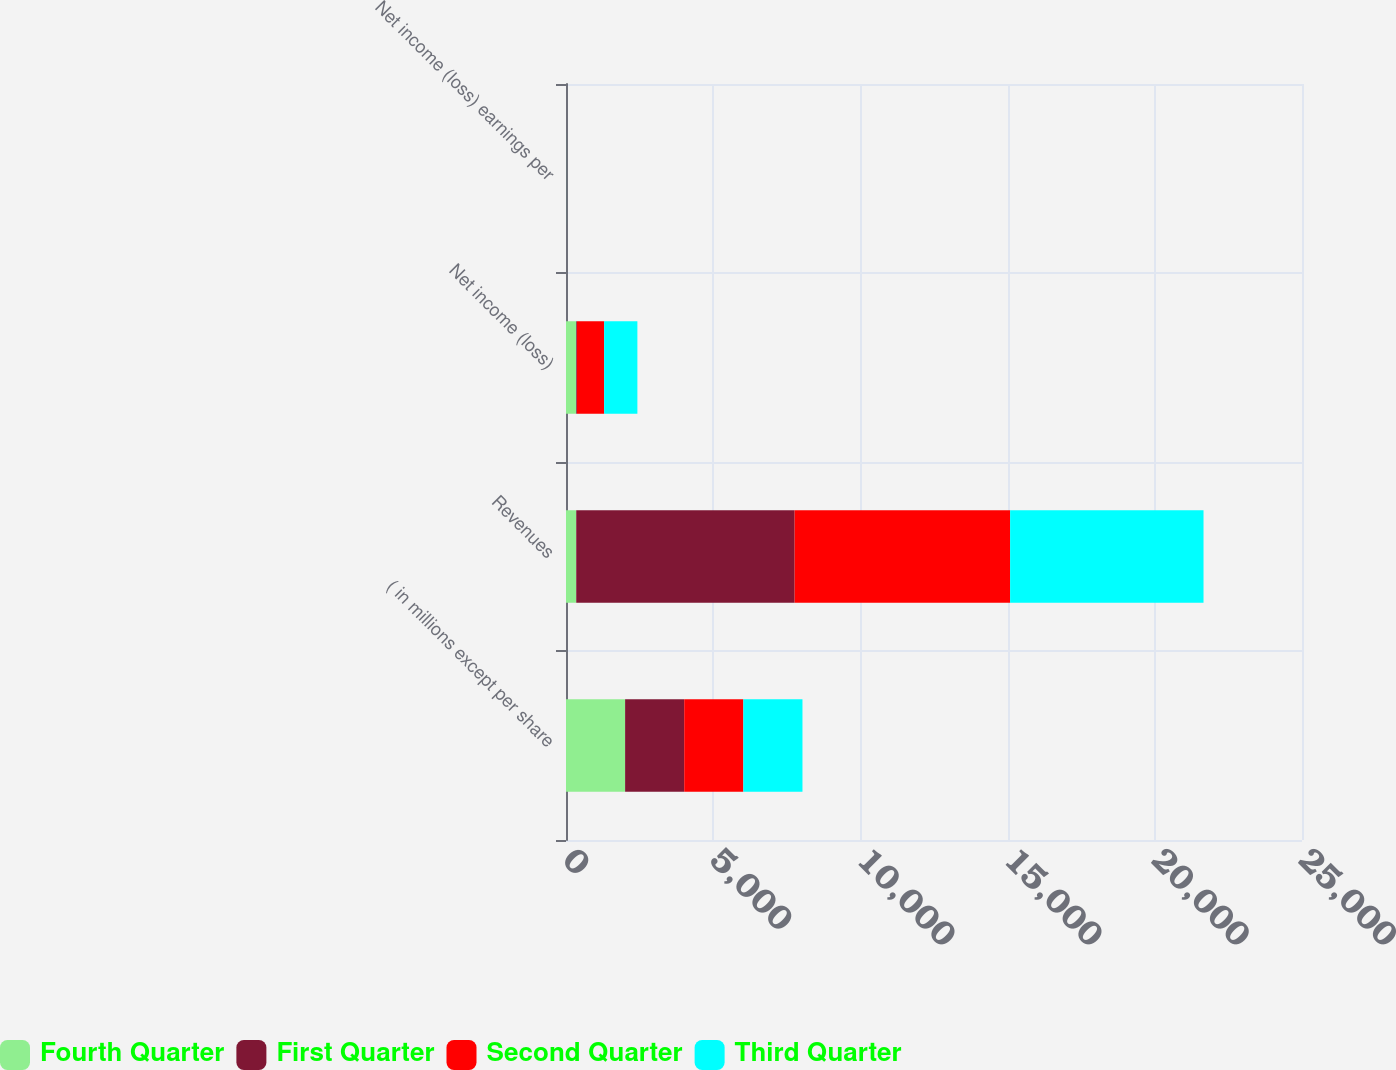Convert chart to OTSL. <chart><loc_0><loc_0><loc_500><loc_500><stacked_bar_chart><ecel><fcel>( in millions except per share<fcel>Revenues<fcel>Net income (loss)<fcel>Net income (loss) earnings per<nl><fcel>Fourth Quarter<fcel>2008<fcel>348<fcel>348<fcel>0.62<nl><fcel>First Quarter<fcel>2008<fcel>7418<fcel>25<fcel>0.05<nl><fcel>Second Quarter<fcel>2008<fcel>7320<fcel>923<fcel>1.71<nl><fcel>Third Quarter<fcel>2008<fcel>6569<fcel>1129<fcel>2.11<nl></chart> 